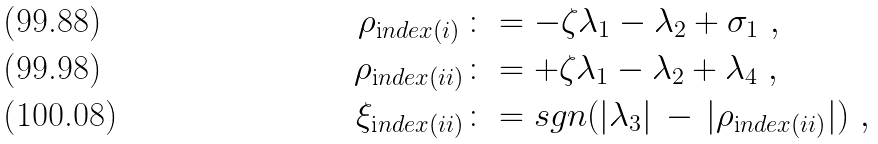<formula> <loc_0><loc_0><loc_500><loc_500>\rho _ { \text  index{(i)\,} } & \colon = - \zeta \lambda _ { 1 } - \lambda _ { 2 } + \sigma _ { 1 } \ , \\ \rho _ { \text  index{(ii)} } & \colon = + \zeta \lambda _ { 1 } - \lambda _ { 2 } + \lambda _ { 4 } \ , \\ \xi _ { \text  index{(ii)} } & \colon = s g n ( | \lambda _ { 3 } | \, - \, | \rho _ { \text  index{(ii)} } | ) \ ,</formula> 